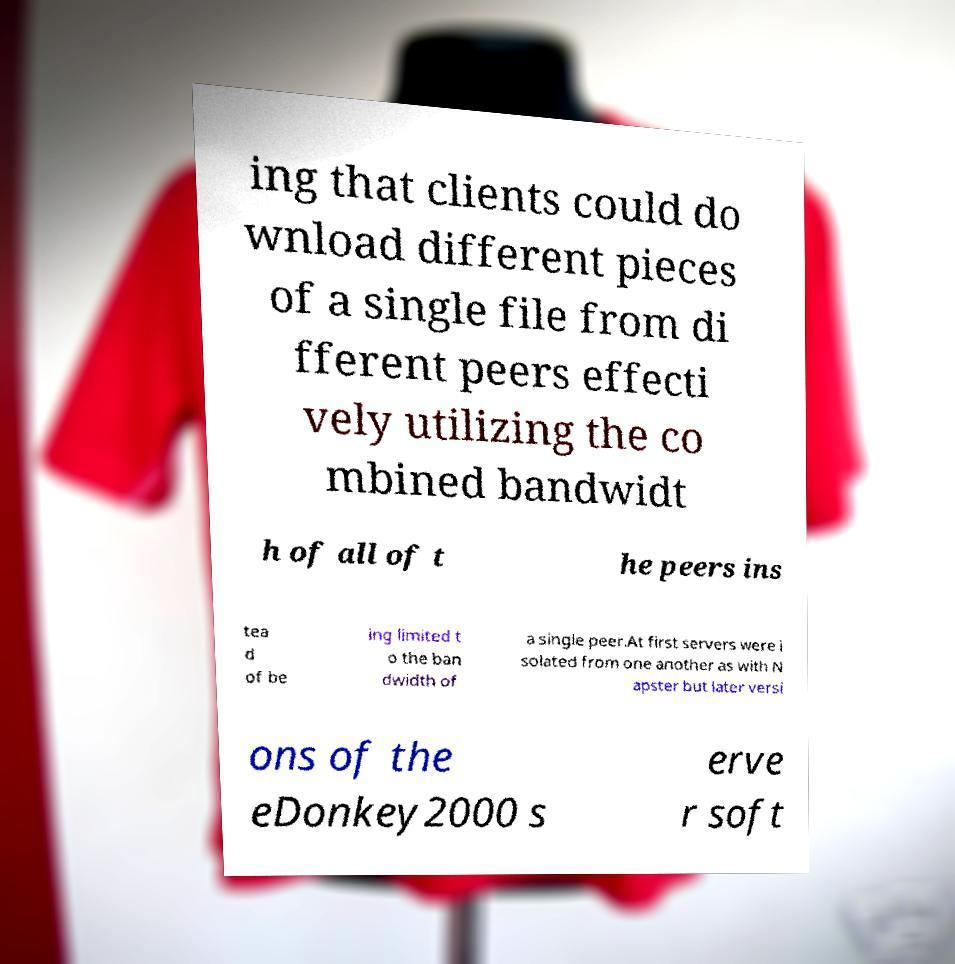Can you read and provide the text displayed in the image?This photo seems to have some interesting text. Can you extract and type it out for me? ing that clients could do wnload different pieces of a single file from di fferent peers effecti vely utilizing the co mbined bandwidt h of all of t he peers ins tea d of be ing limited t o the ban dwidth of a single peer.At first servers were i solated from one another as with N apster but later versi ons of the eDonkey2000 s erve r soft 